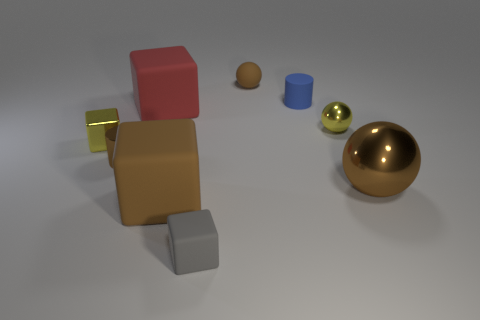Subtract all yellow metal blocks. How many blocks are left? 3 Subtract all blue cylinders. How many cylinders are left? 1 Subtract all balls. How many objects are left? 6 Subtract all brown cylinders. Subtract all red balls. How many cylinders are left? 1 Subtract all red cylinders. How many brown spheres are left? 2 Subtract all large gray shiny cubes. Subtract all red things. How many objects are left? 8 Add 1 tiny blue objects. How many tiny blue objects are left? 2 Add 2 tiny cylinders. How many tiny cylinders exist? 4 Subtract 0 cyan balls. How many objects are left? 9 Subtract 3 balls. How many balls are left? 0 